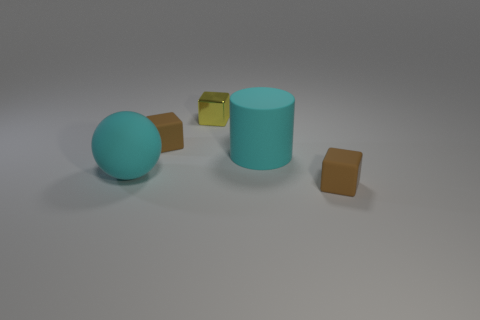Is there anything else that has the same color as the ball?
Provide a succinct answer. Yes. The large thing that is right of the tiny rubber thing that is to the left of the tiny yellow shiny thing is what color?
Your answer should be compact. Cyan. What is the material of the tiny brown object to the left of the tiny brown matte thing on the right side of the cube that is left of the tiny metallic thing?
Offer a terse response. Rubber. How many cyan things have the same size as the yellow metallic block?
Your response must be concise. 0. There is a thing that is both in front of the matte cylinder and to the right of the yellow block; what is it made of?
Give a very brief answer. Rubber. How many small matte blocks are to the right of the yellow thing?
Offer a very short reply. 1. Does the small yellow thing have the same shape as the big cyan rubber thing behind the large rubber ball?
Offer a terse response. No. Is there a small gray metallic thing of the same shape as the yellow shiny object?
Your answer should be compact. No. There is a tiny brown object that is behind the brown rubber block in front of the big rubber ball; what is its shape?
Your answer should be compact. Cube. What shape is the large object that is right of the yellow shiny thing?
Offer a terse response. Cylinder. 